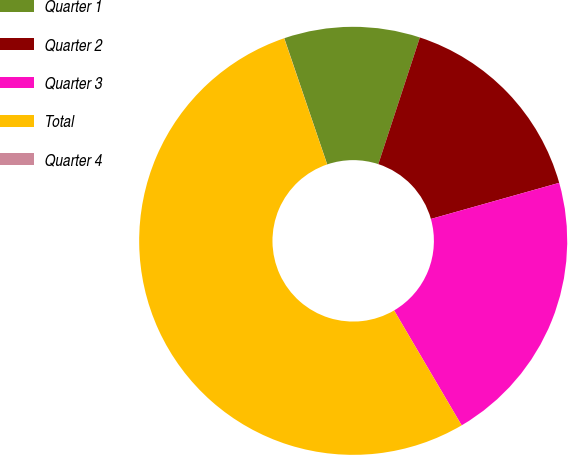<chart> <loc_0><loc_0><loc_500><loc_500><pie_chart><fcel>Quarter 1<fcel>Quarter 2<fcel>Quarter 3<fcel>Total<fcel>Quarter 4<nl><fcel>10.26%<fcel>15.59%<fcel>20.91%<fcel>53.23%<fcel>0.01%<nl></chart> 